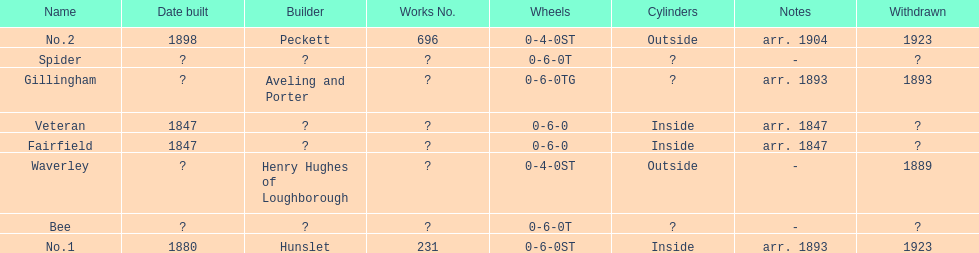Did fairfield or waverley have inside cylinders? Fairfield. 